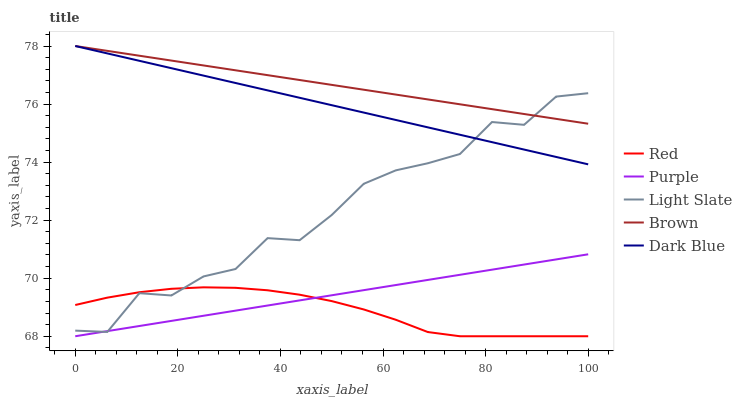Does Red have the minimum area under the curve?
Answer yes or no. Yes. Does Brown have the maximum area under the curve?
Answer yes or no. Yes. Does Light Slate have the minimum area under the curve?
Answer yes or no. No. Does Light Slate have the maximum area under the curve?
Answer yes or no. No. Is Purple the smoothest?
Answer yes or no. Yes. Is Light Slate the roughest?
Answer yes or no. Yes. Is Dark Blue the smoothest?
Answer yes or no. No. Is Dark Blue the roughest?
Answer yes or no. No. Does Purple have the lowest value?
Answer yes or no. Yes. Does Light Slate have the lowest value?
Answer yes or no. No. Does Brown have the highest value?
Answer yes or no. Yes. Does Light Slate have the highest value?
Answer yes or no. No. Is Purple less than Brown?
Answer yes or no. Yes. Is Brown greater than Purple?
Answer yes or no. Yes. Does Purple intersect Red?
Answer yes or no. Yes. Is Purple less than Red?
Answer yes or no. No. Is Purple greater than Red?
Answer yes or no. No. Does Purple intersect Brown?
Answer yes or no. No. 